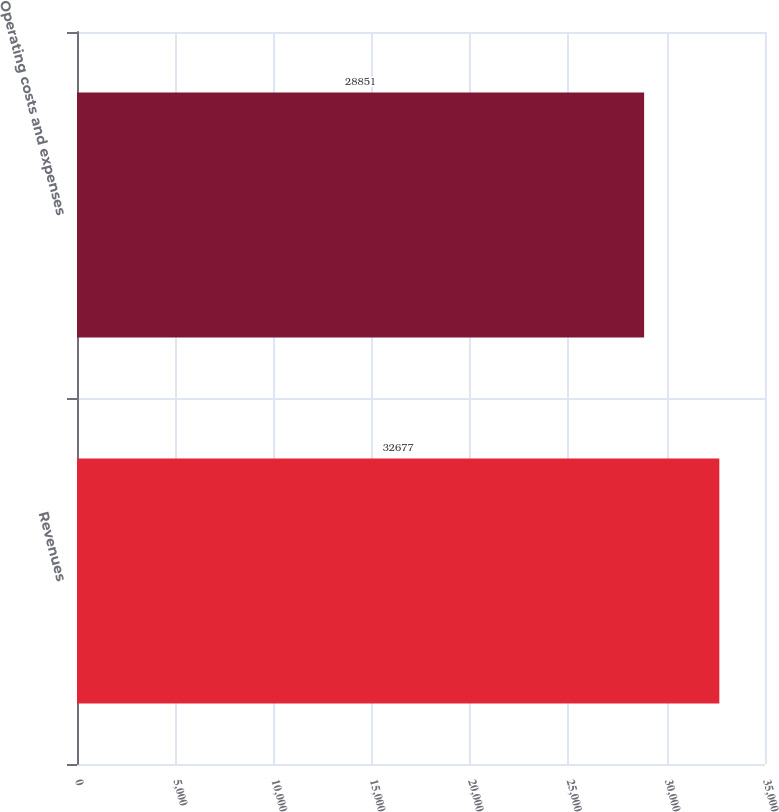Convert chart. <chart><loc_0><loc_0><loc_500><loc_500><bar_chart><fcel>Revenues<fcel>Operating costs and expenses<nl><fcel>32677<fcel>28851<nl></chart> 